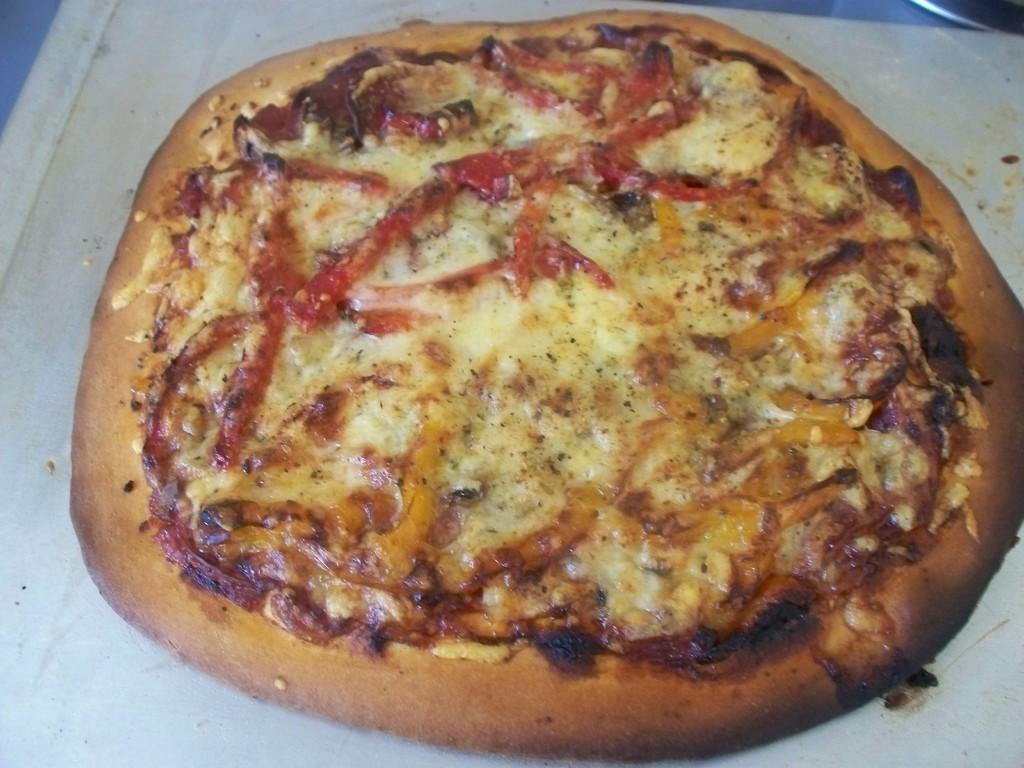What type of food is present on the table in the image? There is pizza on the table. What type of rifle is the governor using to transport the pizza in the image? There is no governor, rifle, or transportation of pizza depicted in the image; it only shows pizza on a table. 